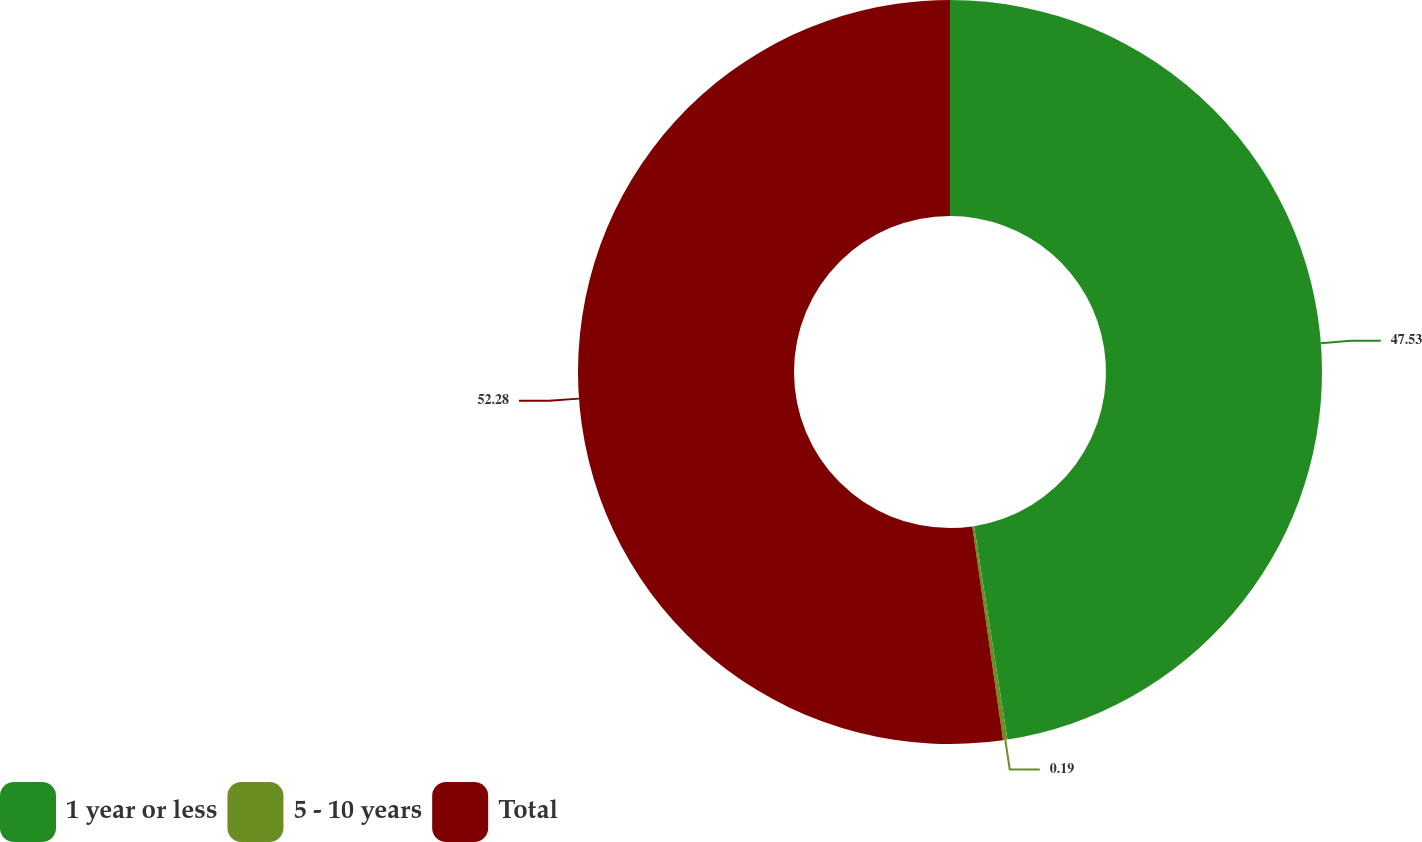<chart> <loc_0><loc_0><loc_500><loc_500><pie_chart><fcel>1 year or less<fcel>5 - 10 years<fcel>Total<nl><fcel>47.53%<fcel>0.19%<fcel>52.28%<nl></chart> 